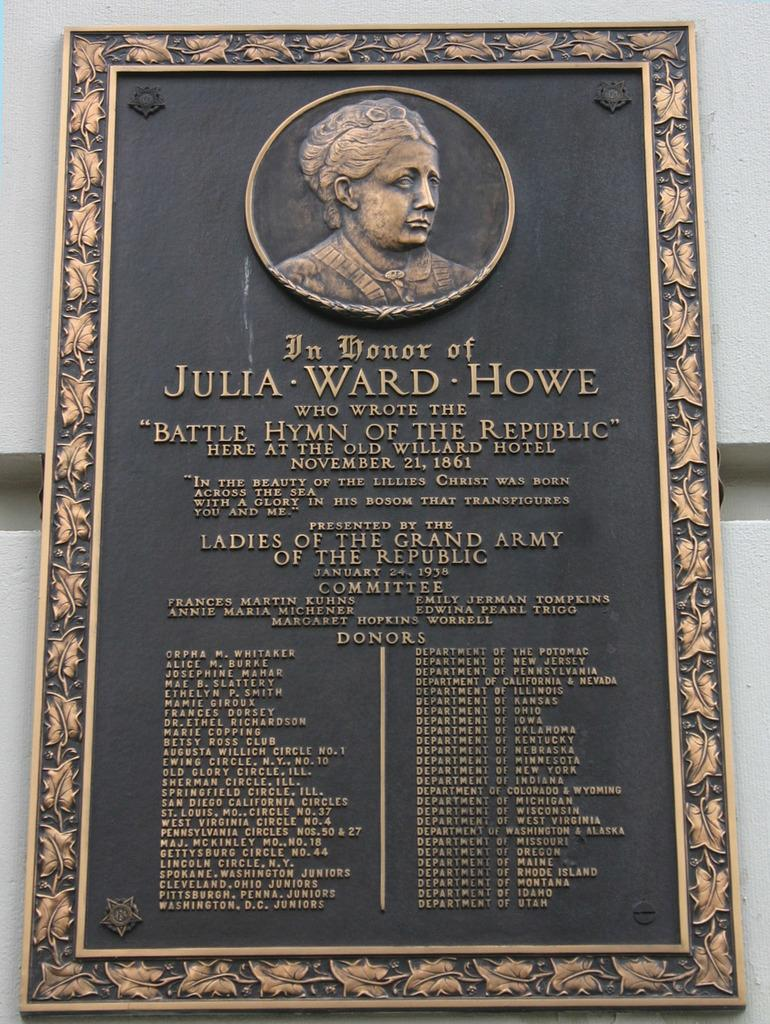<image>
Describe the image concisely. A dedication to Julia Ward Howe and her picture. 